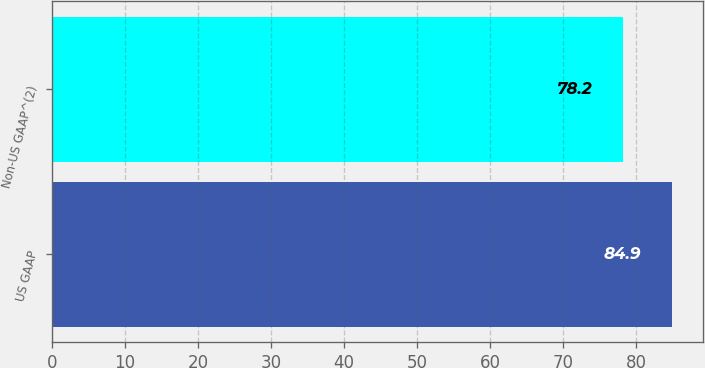<chart> <loc_0><loc_0><loc_500><loc_500><bar_chart><fcel>US GAAP<fcel>Non-US GAAP^(2)<nl><fcel>84.9<fcel>78.2<nl></chart> 